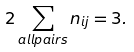<formula> <loc_0><loc_0><loc_500><loc_500>2 \sum _ { a l l p a i r s } n _ { i j } = 3 .</formula> 